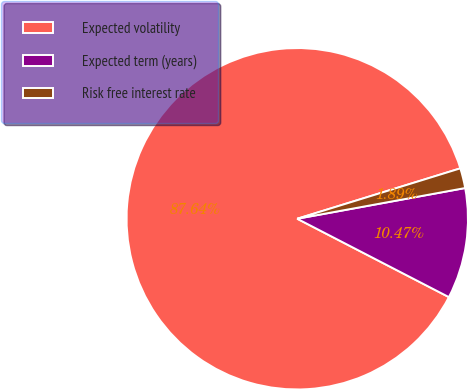Convert chart to OTSL. <chart><loc_0><loc_0><loc_500><loc_500><pie_chart><fcel>Expected volatility<fcel>Expected term (years)<fcel>Risk free interest rate<nl><fcel>87.63%<fcel>10.47%<fcel>1.89%<nl></chart> 